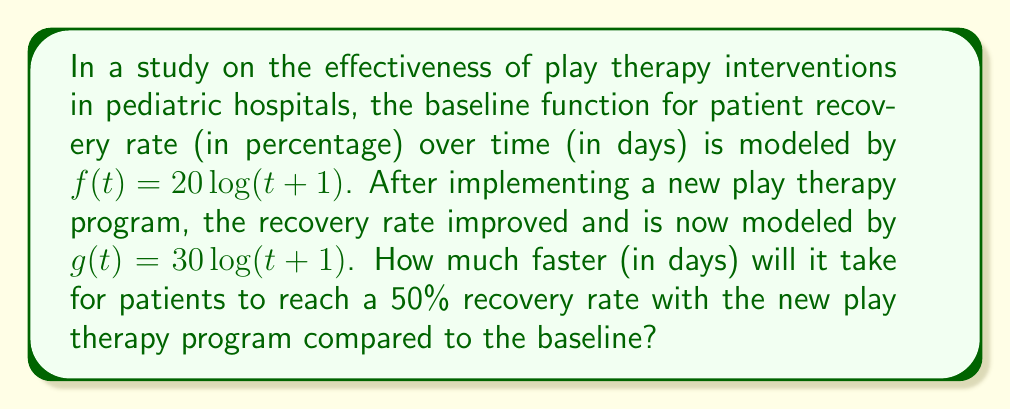Can you answer this question? Let's approach this step-by-step:

1) The baseline function is $f(t) = 20\log(t+1)$
   The new function after play therapy is $g(t) = 30\log(t+1)$

2) We can see that $g(t)$ is a vertical stretch of $f(t)$ by a factor of $\frac{30}{20} = 1.5$

3) We need to find when each function reaches 50%:

   For $f(t)$: $50 = 20\log(t+1)$
   For $g(t)$: $50 = 30\log(t+1)$

4) Solving for $t$ in each case:

   For $f(t)$:
   $\frac{50}{20} = \log(t+1)$
   $2.5 = \log(t+1)$
   $e^{2.5} = t+1$
   $t = e^{2.5} - 1 \approx 11.18$ days

   For $g(t)$:
   $\frac{50}{30} = \log(t+1)$
   $\frac{5}{3} = \log(t+1)$
   $e^{\frac{5}{3}} = t+1$
   $t = e^{\frac{5}{3}} - 1 \approx 4.29$ days

5) The difference in time:
   $11.18 - 4.29 \approx 6.89$ days
Answer: $\approx 6.89$ days 